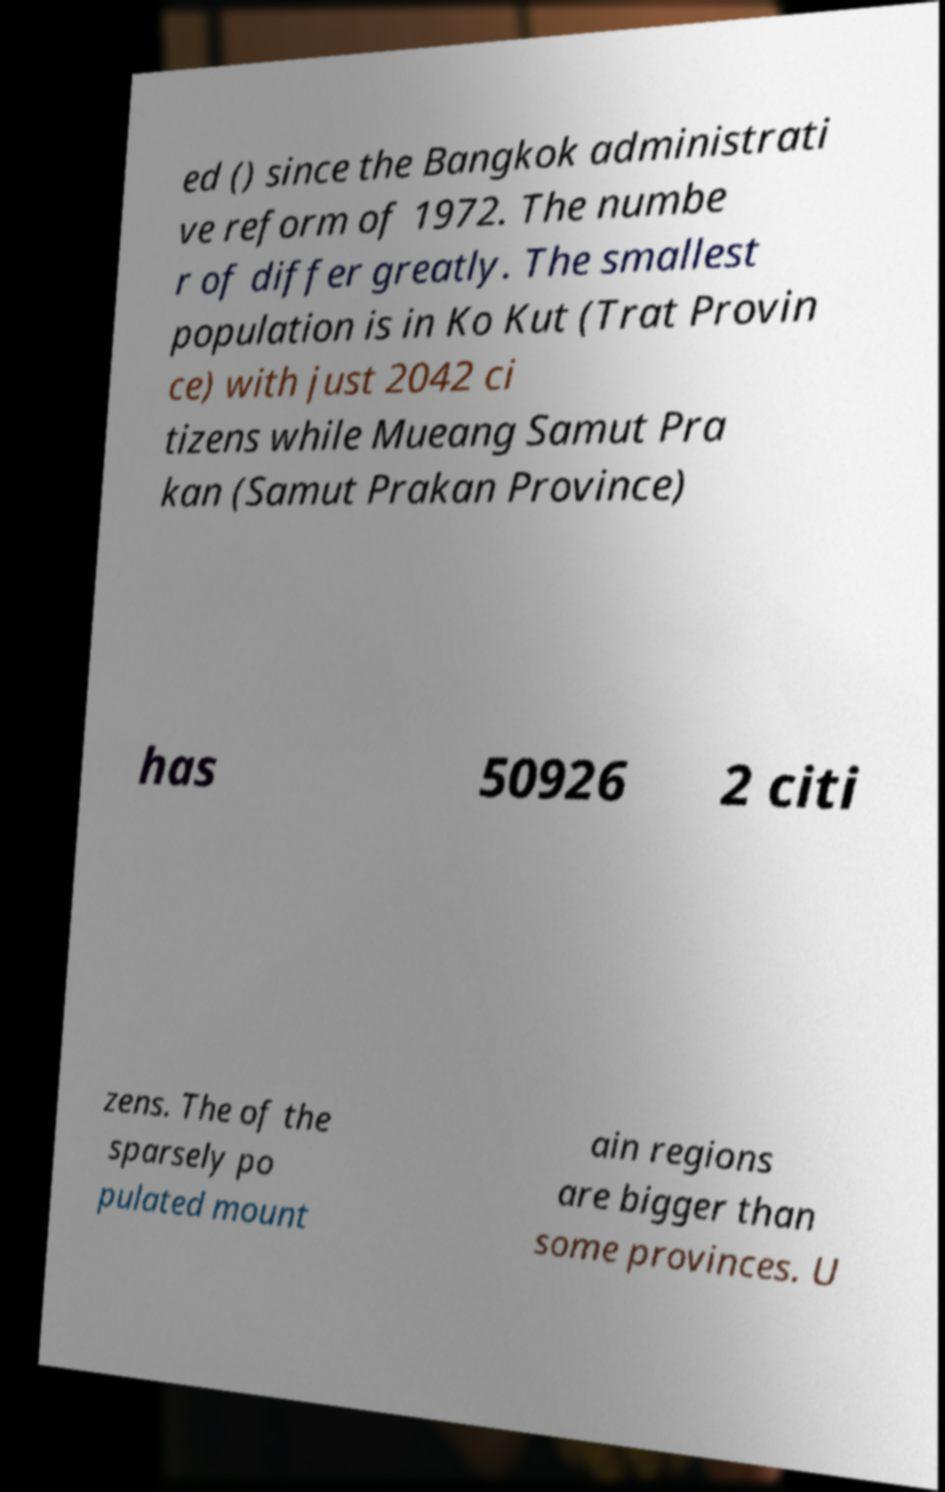Please read and relay the text visible in this image. What does it say? ed () since the Bangkok administrati ve reform of 1972. The numbe r of differ greatly. The smallest population is in Ko Kut (Trat Provin ce) with just 2042 ci tizens while Mueang Samut Pra kan (Samut Prakan Province) has 50926 2 citi zens. The of the sparsely po pulated mount ain regions are bigger than some provinces. U 